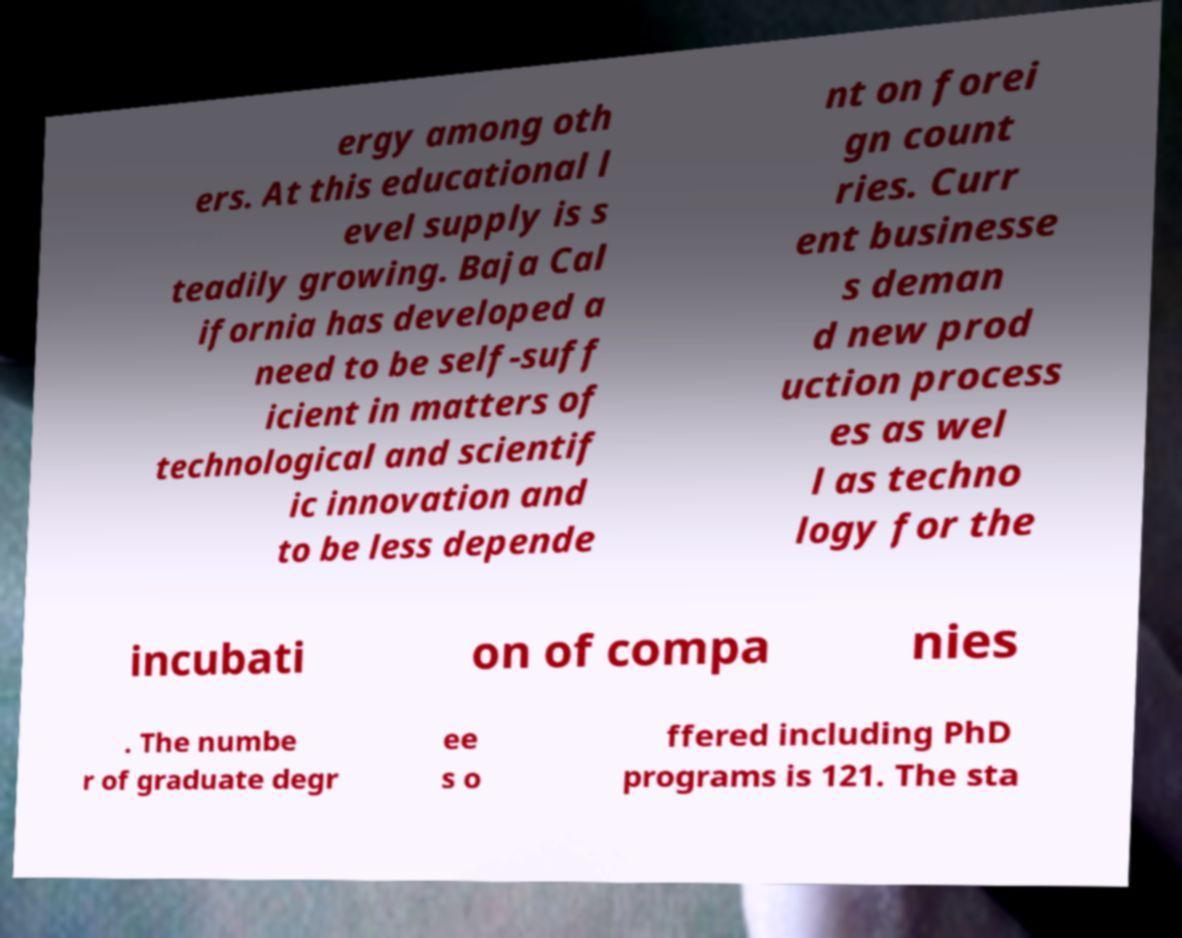There's text embedded in this image that I need extracted. Can you transcribe it verbatim? ergy among oth ers. At this educational l evel supply is s teadily growing. Baja Cal ifornia has developed a need to be self-suff icient in matters of technological and scientif ic innovation and to be less depende nt on forei gn count ries. Curr ent businesse s deman d new prod uction process es as wel l as techno logy for the incubati on of compa nies . The numbe r of graduate degr ee s o ffered including PhD programs is 121. The sta 